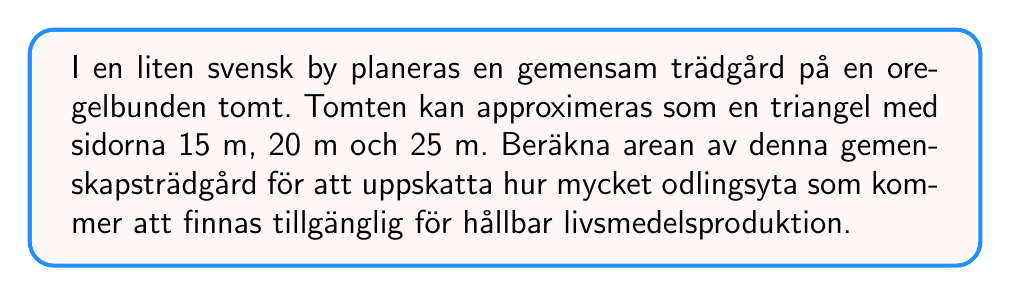Solve this math problem. För att beräkna arean av den triangulära tomten kan vi använda Herons formel:

1) Herons formel: $A = \sqrt{s(s-a)(s-b)(s-c)}$
   där $A$ är arean, $s$ är semiperimetern, och $a$, $b$, $c$ är sidolängderna.

2) Beräkna semiperimetern:
   $s = \frac{a + b + c}{2} = \frac{15 + 20 + 25}{2} = \frac{60}{2} = 30$ m

3) Sätt in värdena i Herons formel:
   $A = \sqrt{30(30-15)(30-20)(30-25)}$
   $= \sqrt{30 \cdot 15 \cdot 10 \cdot 5}$
   $= \sqrt{22500}$
   $= 150$ m²

Därmed är arean av den triangulära gemenskapsträdgården 150 m².
Answer: 150 m² 